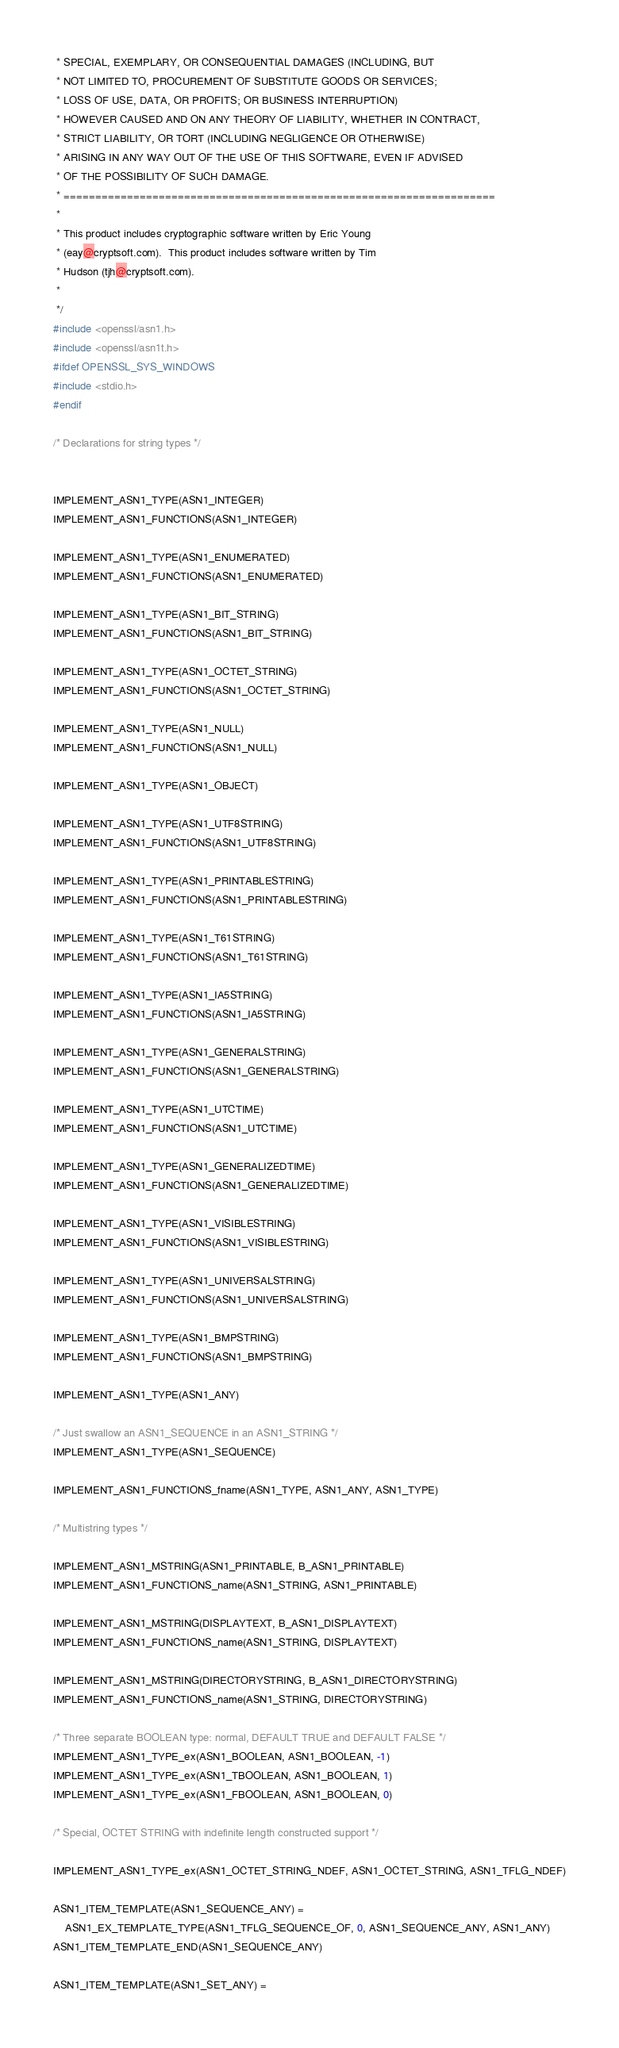<code> <loc_0><loc_0><loc_500><loc_500><_C++_> * SPECIAL, EXEMPLARY, OR CONSEQUENTIAL DAMAGES (INCLUDING, BUT
 * NOT LIMITED TO, PROCUREMENT OF SUBSTITUTE GOODS OR SERVICES;
 * LOSS OF USE, DATA, OR PROFITS; OR BUSINESS INTERRUPTION)
 * HOWEVER CAUSED AND ON ANY THEORY OF LIABILITY, WHETHER IN CONTRACT,
 * STRICT LIABILITY, OR TORT (INCLUDING NEGLIGENCE OR OTHERWISE)
 * ARISING IN ANY WAY OUT OF THE USE OF THIS SOFTWARE, EVEN IF ADVISED
 * OF THE POSSIBILITY OF SUCH DAMAGE.
 * ====================================================================
 *
 * This product includes cryptographic software written by Eric Young
 * (eay@cryptsoft.com).  This product includes software written by Tim
 * Hudson (tjh@cryptsoft.com).
 *
 */
#include <openssl/asn1.h>
#include <openssl/asn1t.h>
#ifdef OPENSSL_SYS_WINDOWS
#include <stdio.h>
#endif

/* Declarations for string types */


IMPLEMENT_ASN1_TYPE(ASN1_INTEGER)
IMPLEMENT_ASN1_FUNCTIONS(ASN1_INTEGER)

IMPLEMENT_ASN1_TYPE(ASN1_ENUMERATED)
IMPLEMENT_ASN1_FUNCTIONS(ASN1_ENUMERATED)

IMPLEMENT_ASN1_TYPE(ASN1_BIT_STRING)
IMPLEMENT_ASN1_FUNCTIONS(ASN1_BIT_STRING)

IMPLEMENT_ASN1_TYPE(ASN1_OCTET_STRING)
IMPLEMENT_ASN1_FUNCTIONS(ASN1_OCTET_STRING)

IMPLEMENT_ASN1_TYPE(ASN1_NULL)
IMPLEMENT_ASN1_FUNCTIONS(ASN1_NULL)

IMPLEMENT_ASN1_TYPE(ASN1_OBJECT)

IMPLEMENT_ASN1_TYPE(ASN1_UTF8STRING)
IMPLEMENT_ASN1_FUNCTIONS(ASN1_UTF8STRING)

IMPLEMENT_ASN1_TYPE(ASN1_PRINTABLESTRING)
IMPLEMENT_ASN1_FUNCTIONS(ASN1_PRINTABLESTRING)

IMPLEMENT_ASN1_TYPE(ASN1_T61STRING)
IMPLEMENT_ASN1_FUNCTIONS(ASN1_T61STRING)

IMPLEMENT_ASN1_TYPE(ASN1_IA5STRING)
IMPLEMENT_ASN1_FUNCTIONS(ASN1_IA5STRING)

IMPLEMENT_ASN1_TYPE(ASN1_GENERALSTRING)
IMPLEMENT_ASN1_FUNCTIONS(ASN1_GENERALSTRING)

IMPLEMENT_ASN1_TYPE(ASN1_UTCTIME)
IMPLEMENT_ASN1_FUNCTIONS(ASN1_UTCTIME)

IMPLEMENT_ASN1_TYPE(ASN1_GENERALIZEDTIME)
IMPLEMENT_ASN1_FUNCTIONS(ASN1_GENERALIZEDTIME)

IMPLEMENT_ASN1_TYPE(ASN1_VISIBLESTRING)
IMPLEMENT_ASN1_FUNCTIONS(ASN1_VISIBLESTRING)

IMPLEMENT_ASN1_TYPE(ASN1_UNIVERSALSTRING)
IMPLEMENT_ASN1_FUNCTIONS(ASN1_UNIVERSALSTRING)

IMPLEMENT_ASN1_TYPE(ASN1_BMPSTRING)
IMPLEMENT_ASN1_FUNCTIONS(ASN1_BMPSTRING)

IMPLEMENT_ASN1_TYPE(ASN1_ANY)

/* Just swallow an ASN1_SEQUENCE in an ASN1_STRING */
IMPLEMENT_ASN1_TYPE(ASN1_SEQUENCE)

IMPLEMENT_ASN1_FUNCTIONS_fname(ASN1_TYPE, ASN1_ANY, ASN1_TYPE)

/* Multistring types */

IMPLEMENT_ASN1_MSTRING(ASN1_PRINTABLE, B_ASN1_PRINTABLE)
IMPLEMENT_ASN1_FUNCTIONS_name(ASN1_STRING, ASN1_PRINTABLE)

IMPLEMENT_ASN1_MSTRING(DISPLAYTEXT, B_ASN1_DISPLAYTEXT)
IMPLEMENT_ASN1_FUNCTIONS_name(ASN1_STRING, DISPLAYTEXT)

IMPLEMENT_ASN1_MSTRING(DIRECTORYSTRING, B_ASN1_DIRECTORYSTRING)
IMPLEMENT_ASN1_FUNCTIONS_name(ASN1_STRING, DIRECTORYSTRING)

/* Three separate BOOLEAN type: normal, DEFAULT TRUE and DEFAULT FALSE */
IMPLEMENT_ASN1_TYPE_ex(ASN1_BOOLEAN, ASN1_BOOLEAN, -1)
IMPLEMENT_ASN1_TYPE_ex(ASN1_TBOOLEAN, ASN1_BOOLEAN, 1)
IMPLEMENT_ASN1_TYPE_ex(ASN1_FBOOLEAN, ASN1_BOOLEAN, 0)

/* Special, OCTET STRING with indefinite length constructed support */

IMPLEMENT_ASN1_TYPE_ex(ASN1_OCTET_STRING_NDEF, ASN1_OCTET_STRING, ASN1_TFLG_NDEF)

ASN1_ITEM_TEMPLATE(ASN1_SEQUENCE_ANY) = 
	ASN1_EX_TEMPLATE_TYPE(ASN1_TFLG_SEQUENCE_OF, 0, ASN1_SEQUENCE_ANY, ASN1_ANY)
ASN1_ITEM_TEMPLATE_END(ASN1_SEQUENCE_ANY)

ASN1_ITEM_TEMPLATE(ASN1_SET_ANY) = </code> 